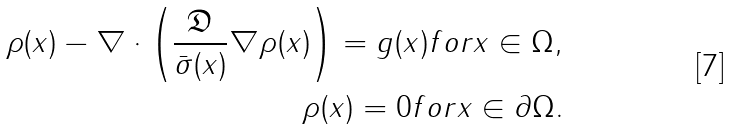Convert formula to latex. <formula><loc_0><loc_0><loc_500><loc_500>\rho ( x ) - \nabla \cdot \left ( \frac { \mathfrak { D } } { \bar { \sigma } ( x ) } \nabla \rho ( x ) \right ) = g ( x ) f o r x \in \Omega , \\ \rho ( x ) = 0 f o r x \in \partial \Omega .</formula> 